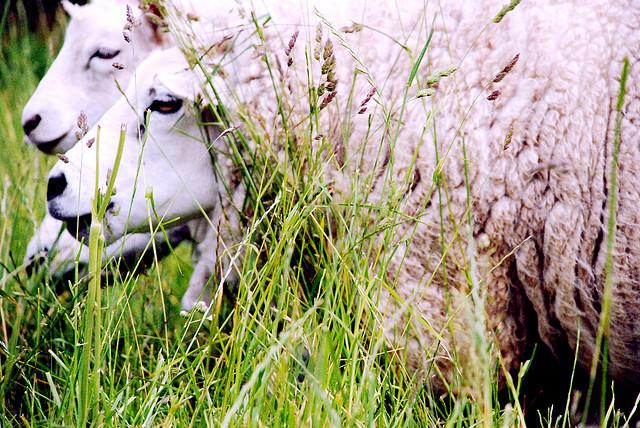What number of long grass blades are there?
Write a very short answer. 100. How many sheep are there?
Concise answer only. 3. What type of animals are these?
Give a very brief answer. Sheep. Has this photo been color corrected?
Quick response, please. Yes. Are the sheep clean?
Write a very short answer. Yes. How many lamb are in the field?
Concise answer only. 3. Which lamb is spotted?
Short answer required. None. What are the lambs laying on?
Write a very short answer. Grass. 